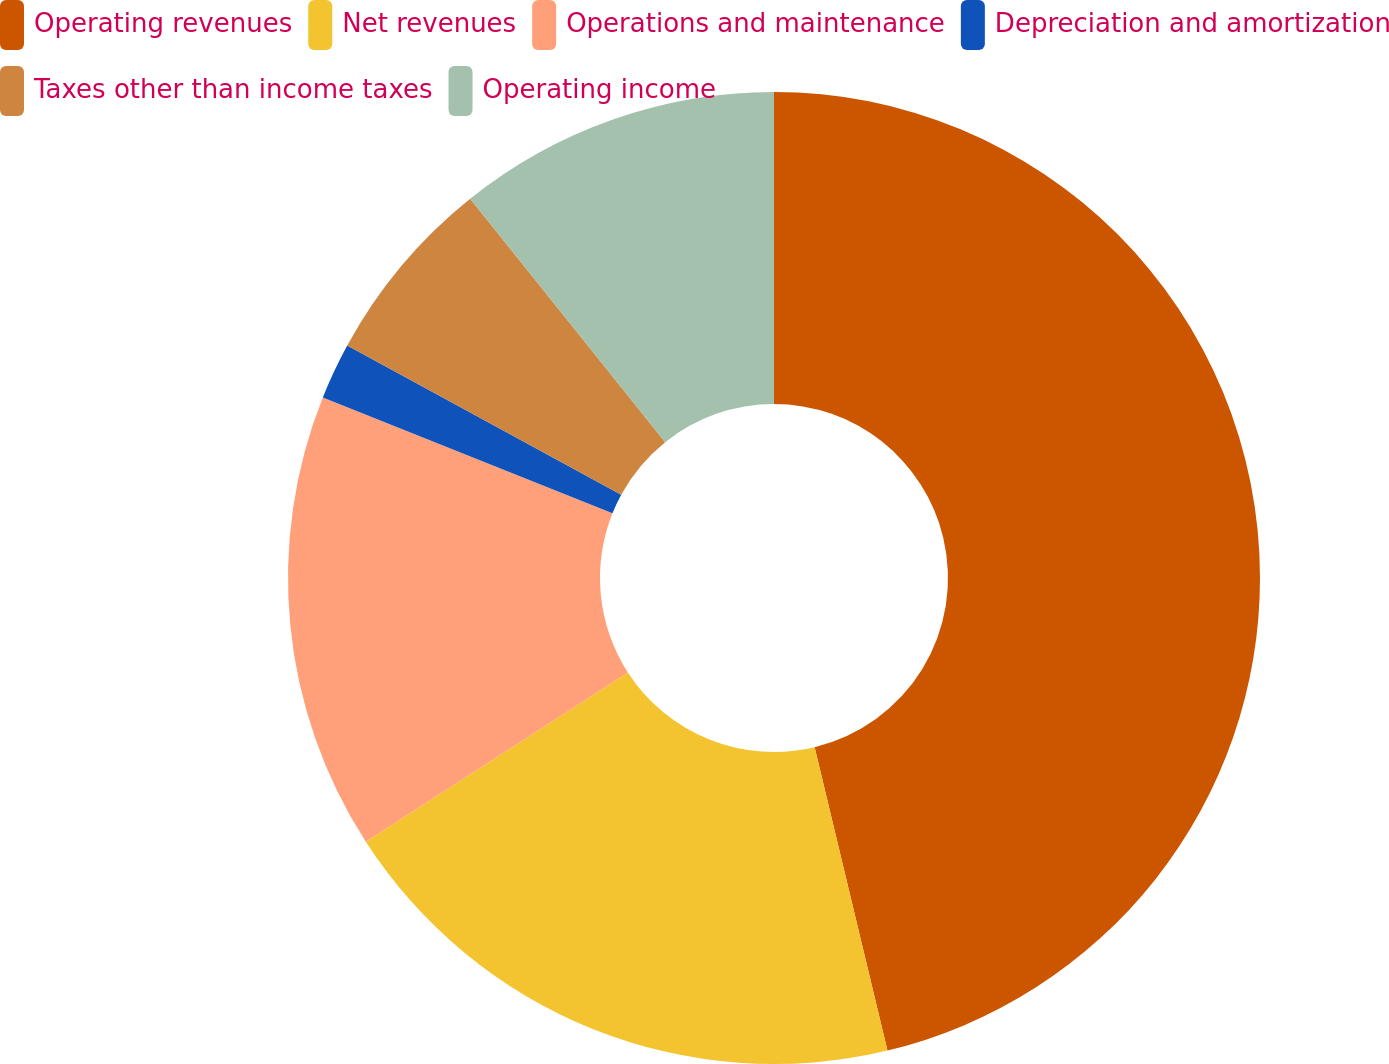Convert chart to OTSL. <chart><loc_0><loc_0><loc_500><loc_500><pie_chart><fcel>Operating revenues<fcel>Net revenues<fcel>Operations and maintenance<fcel>Depreciation and amortization<fcel>Taxes other than income taxes<fcel>Operating income<nl><fcel>46.25%<fcel>19.62%<fcel>15.19%<fcel>1.88%<fcel>6.31%<fcel>10.75%<nl></chart> 